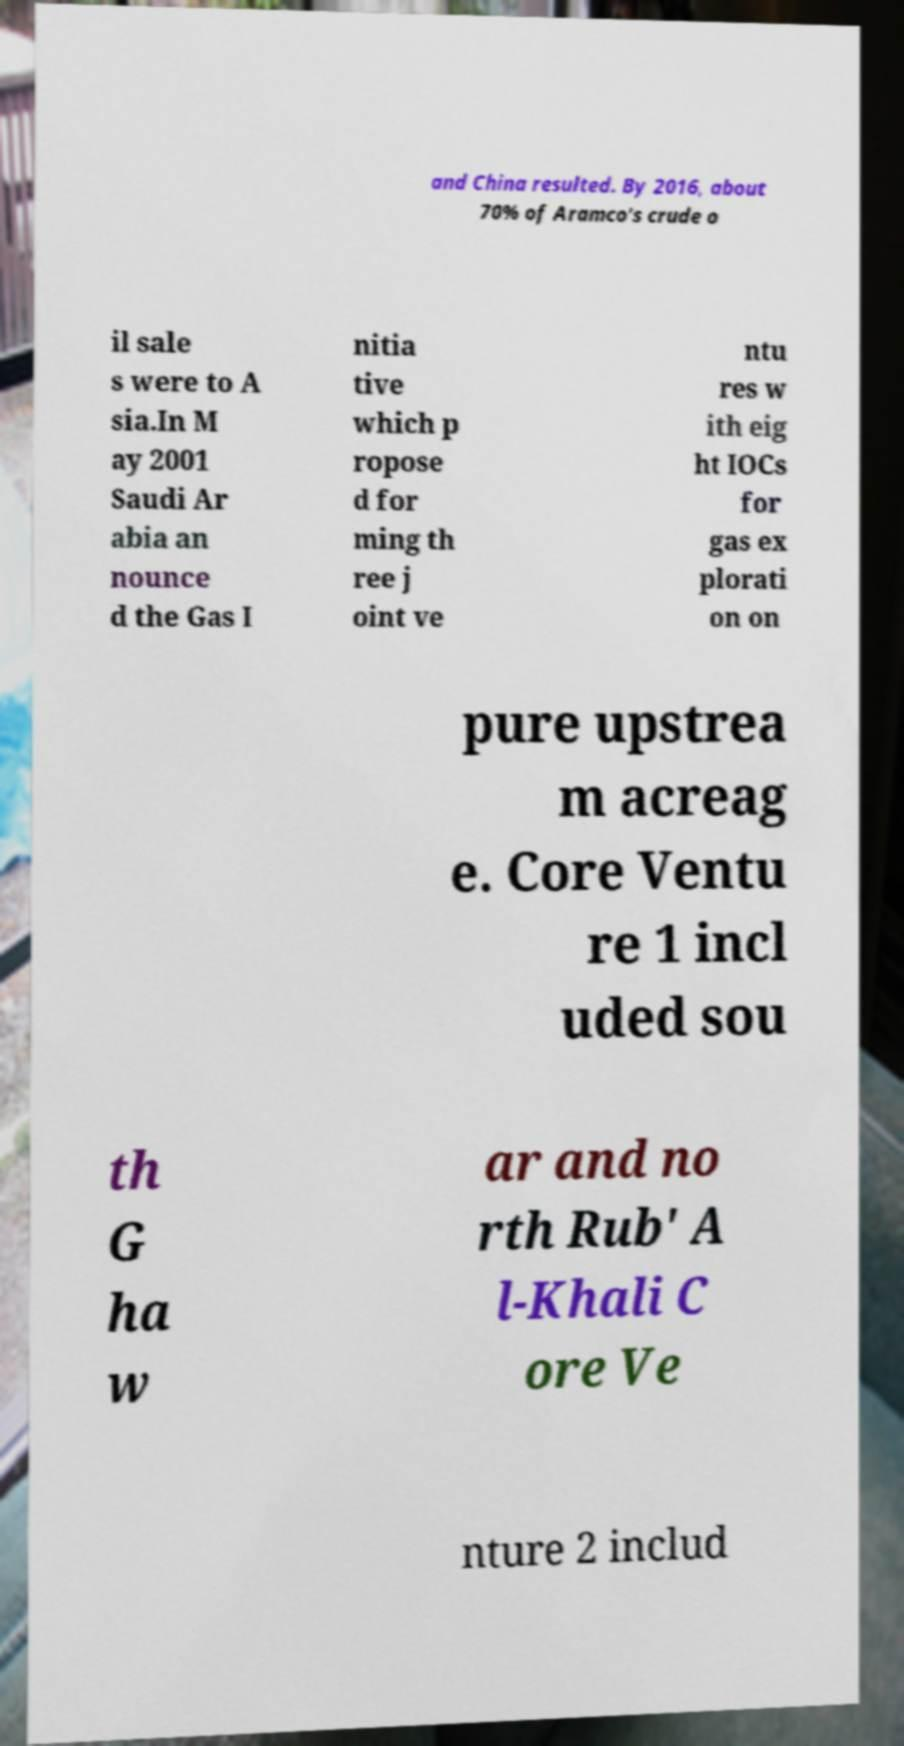I need the written content from this picture converted into text. Can you do that? and China resulted. By 2016, about 70% of Aramco's crude o il sale s were to A sia.In M ay 2001 Saudi Ar abia an nounce d the Gas I nitia tive which p ropose d for ming th ree j oint ve ntu res w ith eig ht IOCs for gas ex plorati on on pure upstrea m acreag e. Core Ventu re 1 incl uded sou th G ha w ar and no rth Rub' A l-Khali C ore Ve nture 2 includ 